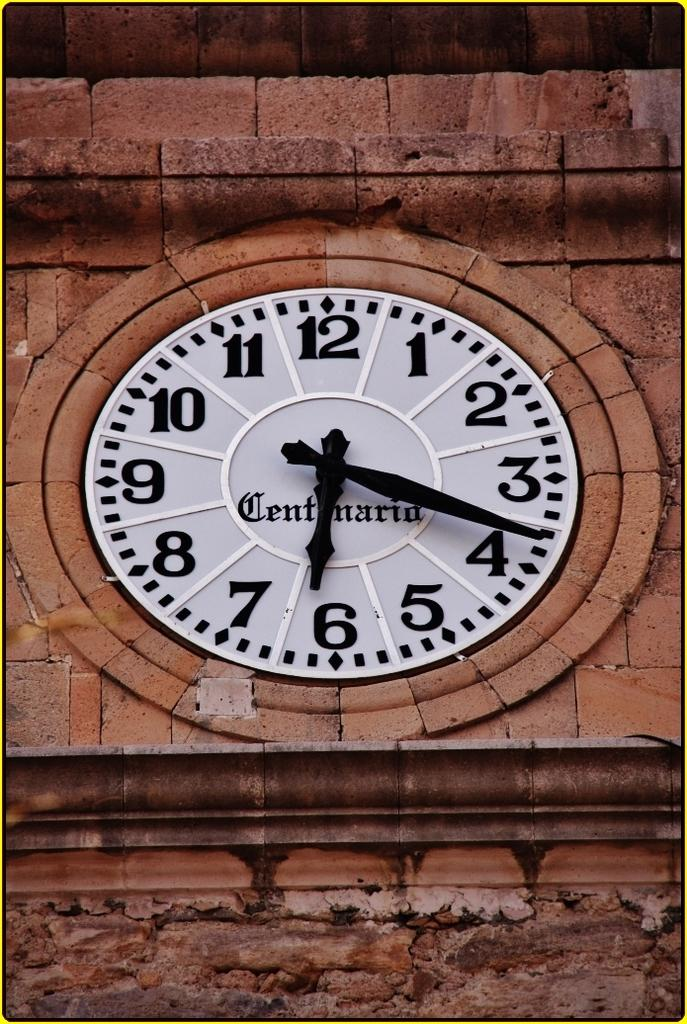<image>
Render a clear and concise summary of the photo. A clock surrounded by stone reads the time as 6:18 on its face. 